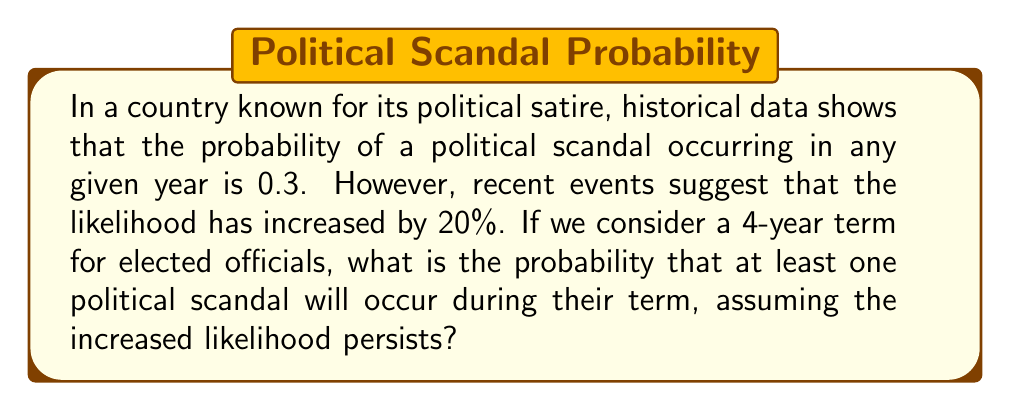Could you help me with this problem? Let's approach this step-by-step:

1) First, we need to calculate the new probability of a scandal occurring in a given year:
   Original probability: $p = 0.3$
   Increase: $20\% = 0.2$
   New probability: $p_{new} = p + (p \times 0.2) = 0.3 + (0.3 \times 0.2) = 0.36$

2) Now, we want to find the probability of at least one scandal in 4 years. It's often easier to calculate the probability of the complement event (no scandals in 4 years) and subtract from 1.

3) The probability of no scandal in a given year is:
   $1 - p_{new} = 1 - 0.36 = 0.64$

4) For no scandals to occur in 4 years, we need this to happen 4 times in a row. Assuming independence, we multiply these probabilities:
   $P(\text{no scandals in 4 years}) = 0.64^4 = 0.1678$

5) Therefore, the probability of at least one scandal in 4 years is:
   $P(\text{at least one scandal}) = 1 - P(\text{no scandals}) = 1 - 0.1678 = 0.8322$

6) Converting to a percentage:
   $0.8322 \times 100\% = 83.22\%$
Answer: 83.22% 